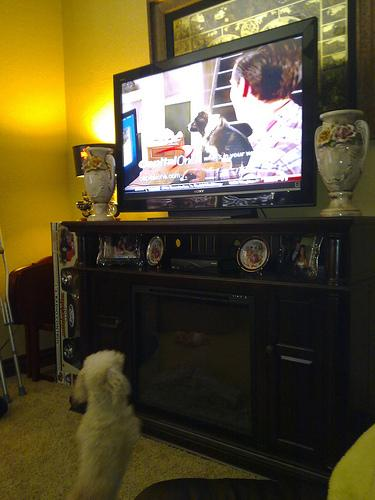What objects can be seen on the entertainment center next to the television, and what is the main color of the wall? We can see decorative vases, plates, and a framed photograph on the entertainment center. The wall is yellow. Provide a brief description of the scene in the image. The scene shows a living room with a large black flat screen television displaying an ad, next to decorative objects such as vases, plates, and a framed photograph, all while a small white dog is watching. Identify the primary object in the image and mention its state. A large black flat screen television is turned on and displaying CapitalOne ad. Analyze the sentiment of the image and describe any object interactions taking place. The image has a cozy and inviting sentiment, depicting a small white dog watching a large black flat screen television, surrounded by decorative items in a living room setting. Explain the image's primary object and its surroundings. The primary object is a large black flat screen television, located in a dark wooden entertainment center. There are decorative vases on the sides and an electronic fireplace below it. Elaborate on the physical appearance of the dog that can be seen in the image. The dog is small and white, possibly a poodle, with a cute expression as it attentively watches the television. What is the primary object in the image and count the number of dogs in the image? The primary object is a large black flat screen television, and there is one dog in the image. Count how many crutches are visible in the image, and mention any other object adjacent to them. There are no crutches visible in the image. What type of animal can be seen in the image and how many decorative plates are displayed? There is a dog in the image, and we can see three decorative plates. Mention the type of flooring in the image and describe the color and texture. The flooring is carpeted, appearing soft and comfortable, in a beige shade. What is the primary color of the crutches in the image? There are no crutches in the image. Create a short story with the elements in the image. Once upon a time, in a cozy living room with a yellow wall, a little white dog named Pippin spent his evenings watching TV. Pippin was enamoured with the dancing images on the large black flat screen, right above an elegant electronic fireplace. Intrigued by mementos on the mantel, Pippin dreamed of adventures. Is the carpet on the floor green? No, the carpet is beige. Describe the scene in a poetic style. Amidst the golden wall, a tiny canine gazes at the screen so tall. Flickering lights cast shadows around, while images on the mantle abound. Explain the features of the electronic fireplace in the image. The electronic fireplace has a dark wood frame, a neatly organized row of fake logs inside, and is situated within the larger entertainment center. How would you describe the carpet texture? Soft and plush Describe the decorative plate on the shelf. Small, possibly china or porcelain, with intricate design and placed on a stand. Imagine a scene where the dog is interacting with the objects in the image. Pippin, the curious little poodle, finds a magical remote control next to the vases. With a gentle nudge, the television transforms into a portal leading him to embark on spectacular adventures. Is there a real or an electronic fireplace in the image? Electronic fireplace Is the dog in the image sitting or standing? Sitting What is the dog in the image doing? Watching television Is the carpet white or beige? Beige Describe the image in a news reporter style. In this modern living room setting, a small white poodle intently watches a large black flat screen television. The room features a dark wooden entertainment center and an electronic fireplace, along with various decorative items such as a vase and plates. Read any text visible in the image. CapitalOne Are the crutches leaning against the wall? There are no crutches in the image. Identify the breed of the small white dog. Poodle What is the color of the entertainment center and its material? Dark wooden Identify any brand or advertisement visible on the television screen. CapitalOne ad What type of object(s) can be seen on either side of the television? Vases 